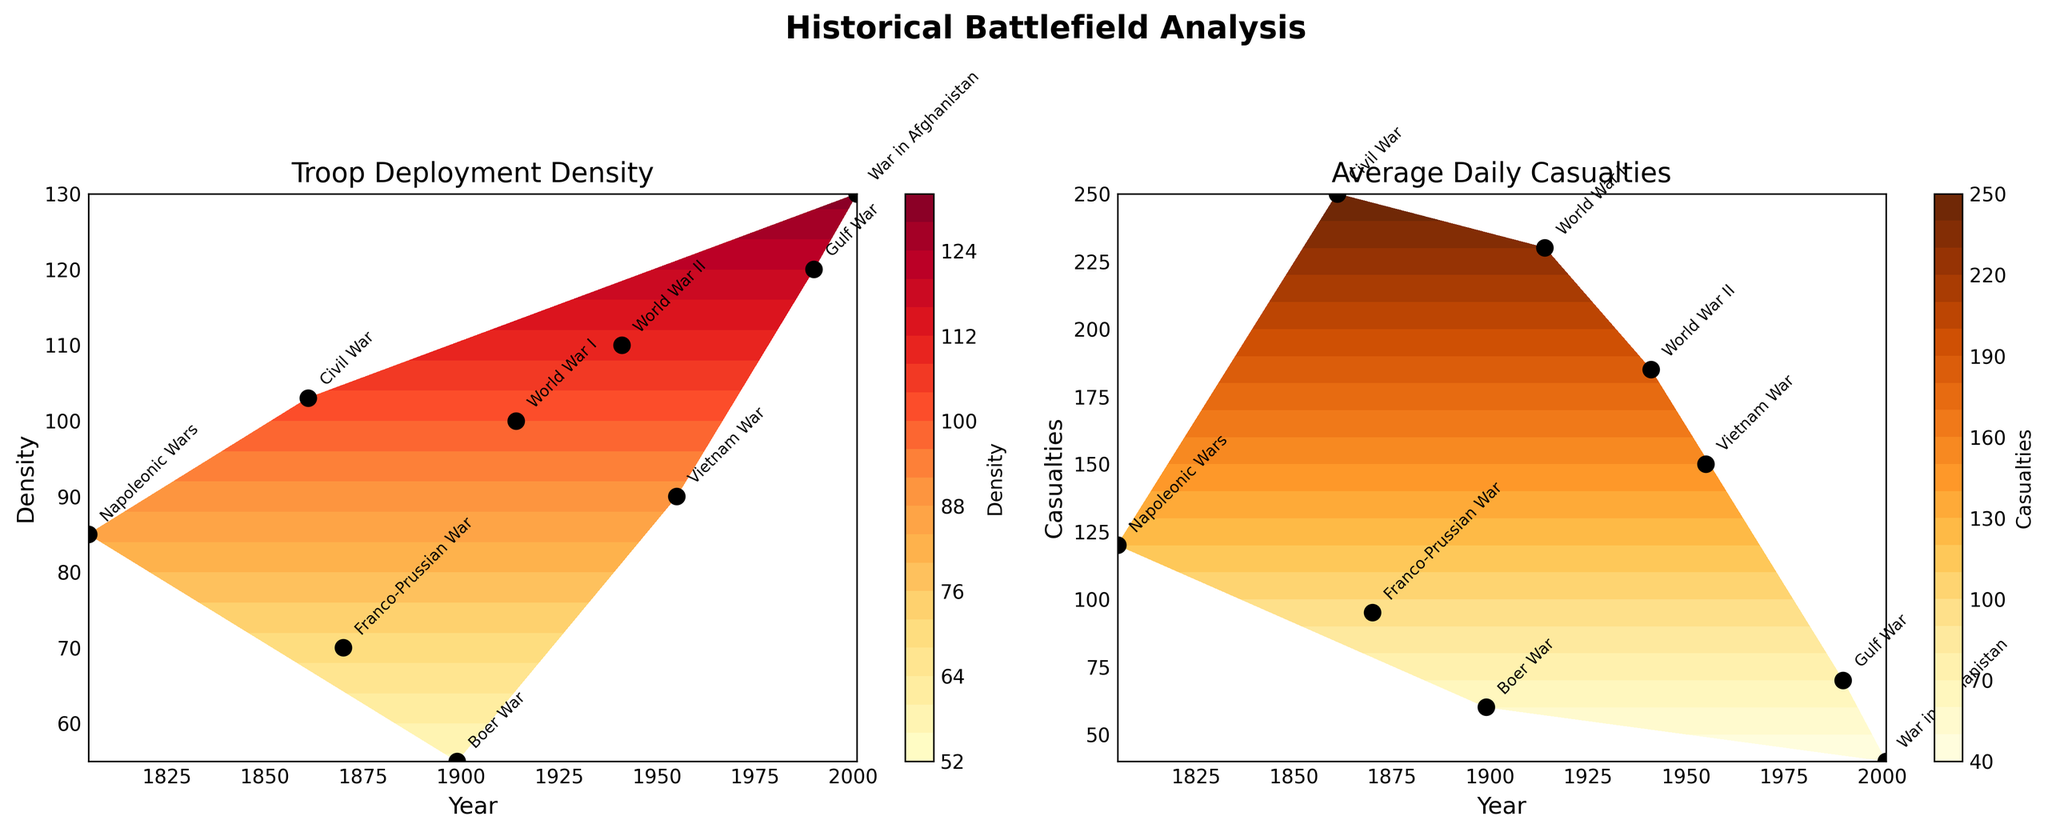What are the two main titles of the subplots? The titles are found at the top of each subplot. The first subplot's title is "Troop Deployment Density" and the second subplot's title is "Average Daily Casualties."
Answer: Troop Deployment Density, Average Daily Casualties How many data points are plotted in each subplot? The number of data points can be counted from the black dots in each subplot. There are 9 data points in each subplot.
Answer: 9 Which conflict saw the highest troop deployment density? The highest value on the y-axis of the first subplot corresponds to the War in Afghanistan. The War in Afghanistan has a troop deployment density of 130.
Answer: War in Afghanistan Which conflict registered the highest average daily casualties? The highest value on the y-axis of the second subplot corresponds to the Civil War. The Civil War has an average daily casualty rate of 250.
Answer: Civil War During which two conflicts did the USA experience both high troop deployment density and high average daily casualties? By examining the two subplots, the USA had high values in both categories during World War II and the Civil War.
Answer: Civil War, World War II Compare the troop deployment density of the Napoleonic Wars and the Gulf War. Which one was higher? On the x-axis, locate the years for the Napoleonic Wars and the Gulf War. Looking at the y-axis of the first subplot, the Gulf War had a higher troop deployment density (120) compared to the Napoleonic Wars (85).
Answer: Gulf War Which conflict saw the lowest average daily casualties and what was the value? The second subplot shows the lowest value on the y-axis corresponding to the War in Afghanistan. The value is 40 average daily casualties.
Answer: War in Afghanistan, 40 Compare the average daily casualties during World War I and World War II. Which was greater? On the x-axis, locate World War I and World War II. The y-axis value of the second subplot shows World War I had 230 average daily casualties, while World War II had 185. So, World War I had greater average daily casualties.
Answer: World War I What is the year range for the conflict with the highest troop deployment density? Locate the highest point on the y-axis of the first subplot and find its corresponding year range. The highest troop deployment density corresponds to the War in Afghanistan, which ranges from 2001 to 2021.
Answer: 2001-2021 During the Boer War, what were the approximate troop deployment density and average daily casualties? Locate the Boer War on the x-axis in both subplots. The y-axis values show that the troop deployment density was approximately 55, and the average daily casualties were approximately 60.
Answer: 55, 60 